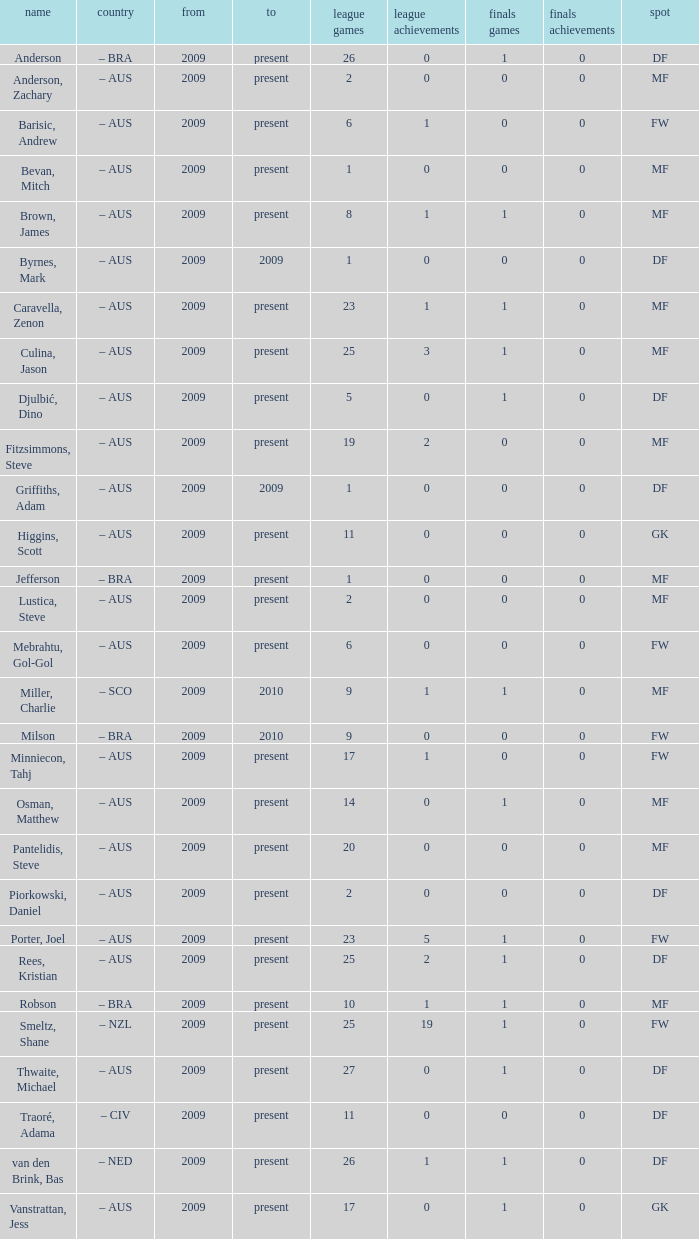Name the position for van den brink, bas DF. 